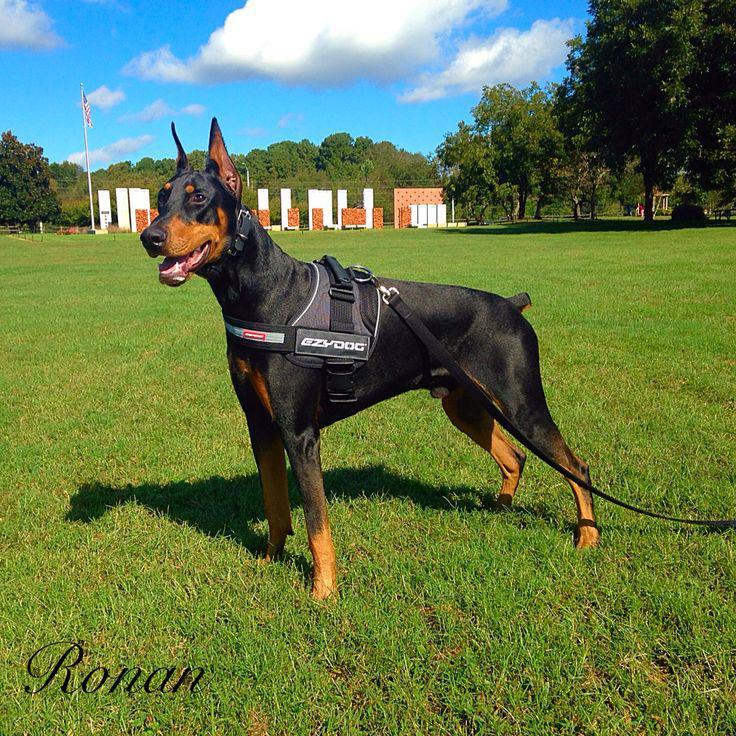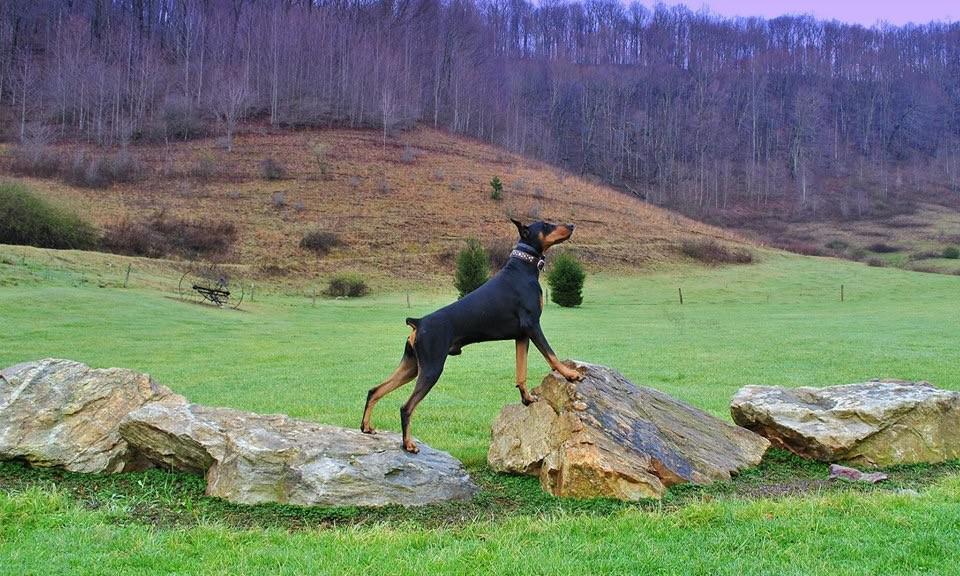The first image is the image on the left, the second image is the image on the right. Evaluate the accuracy of this statement regarding the images: "A black dog is facing left while wearing a harness.". Is it true? Answer yes or no. Yes. The first image is the image on the left, the second image is the image on the right. Considering the images on both sides, is "One image contains one left-facing doberman with pointy ears and docked tail standing in profile and wearing a vest-type harness." valid? Answer yes or no. Yes. 